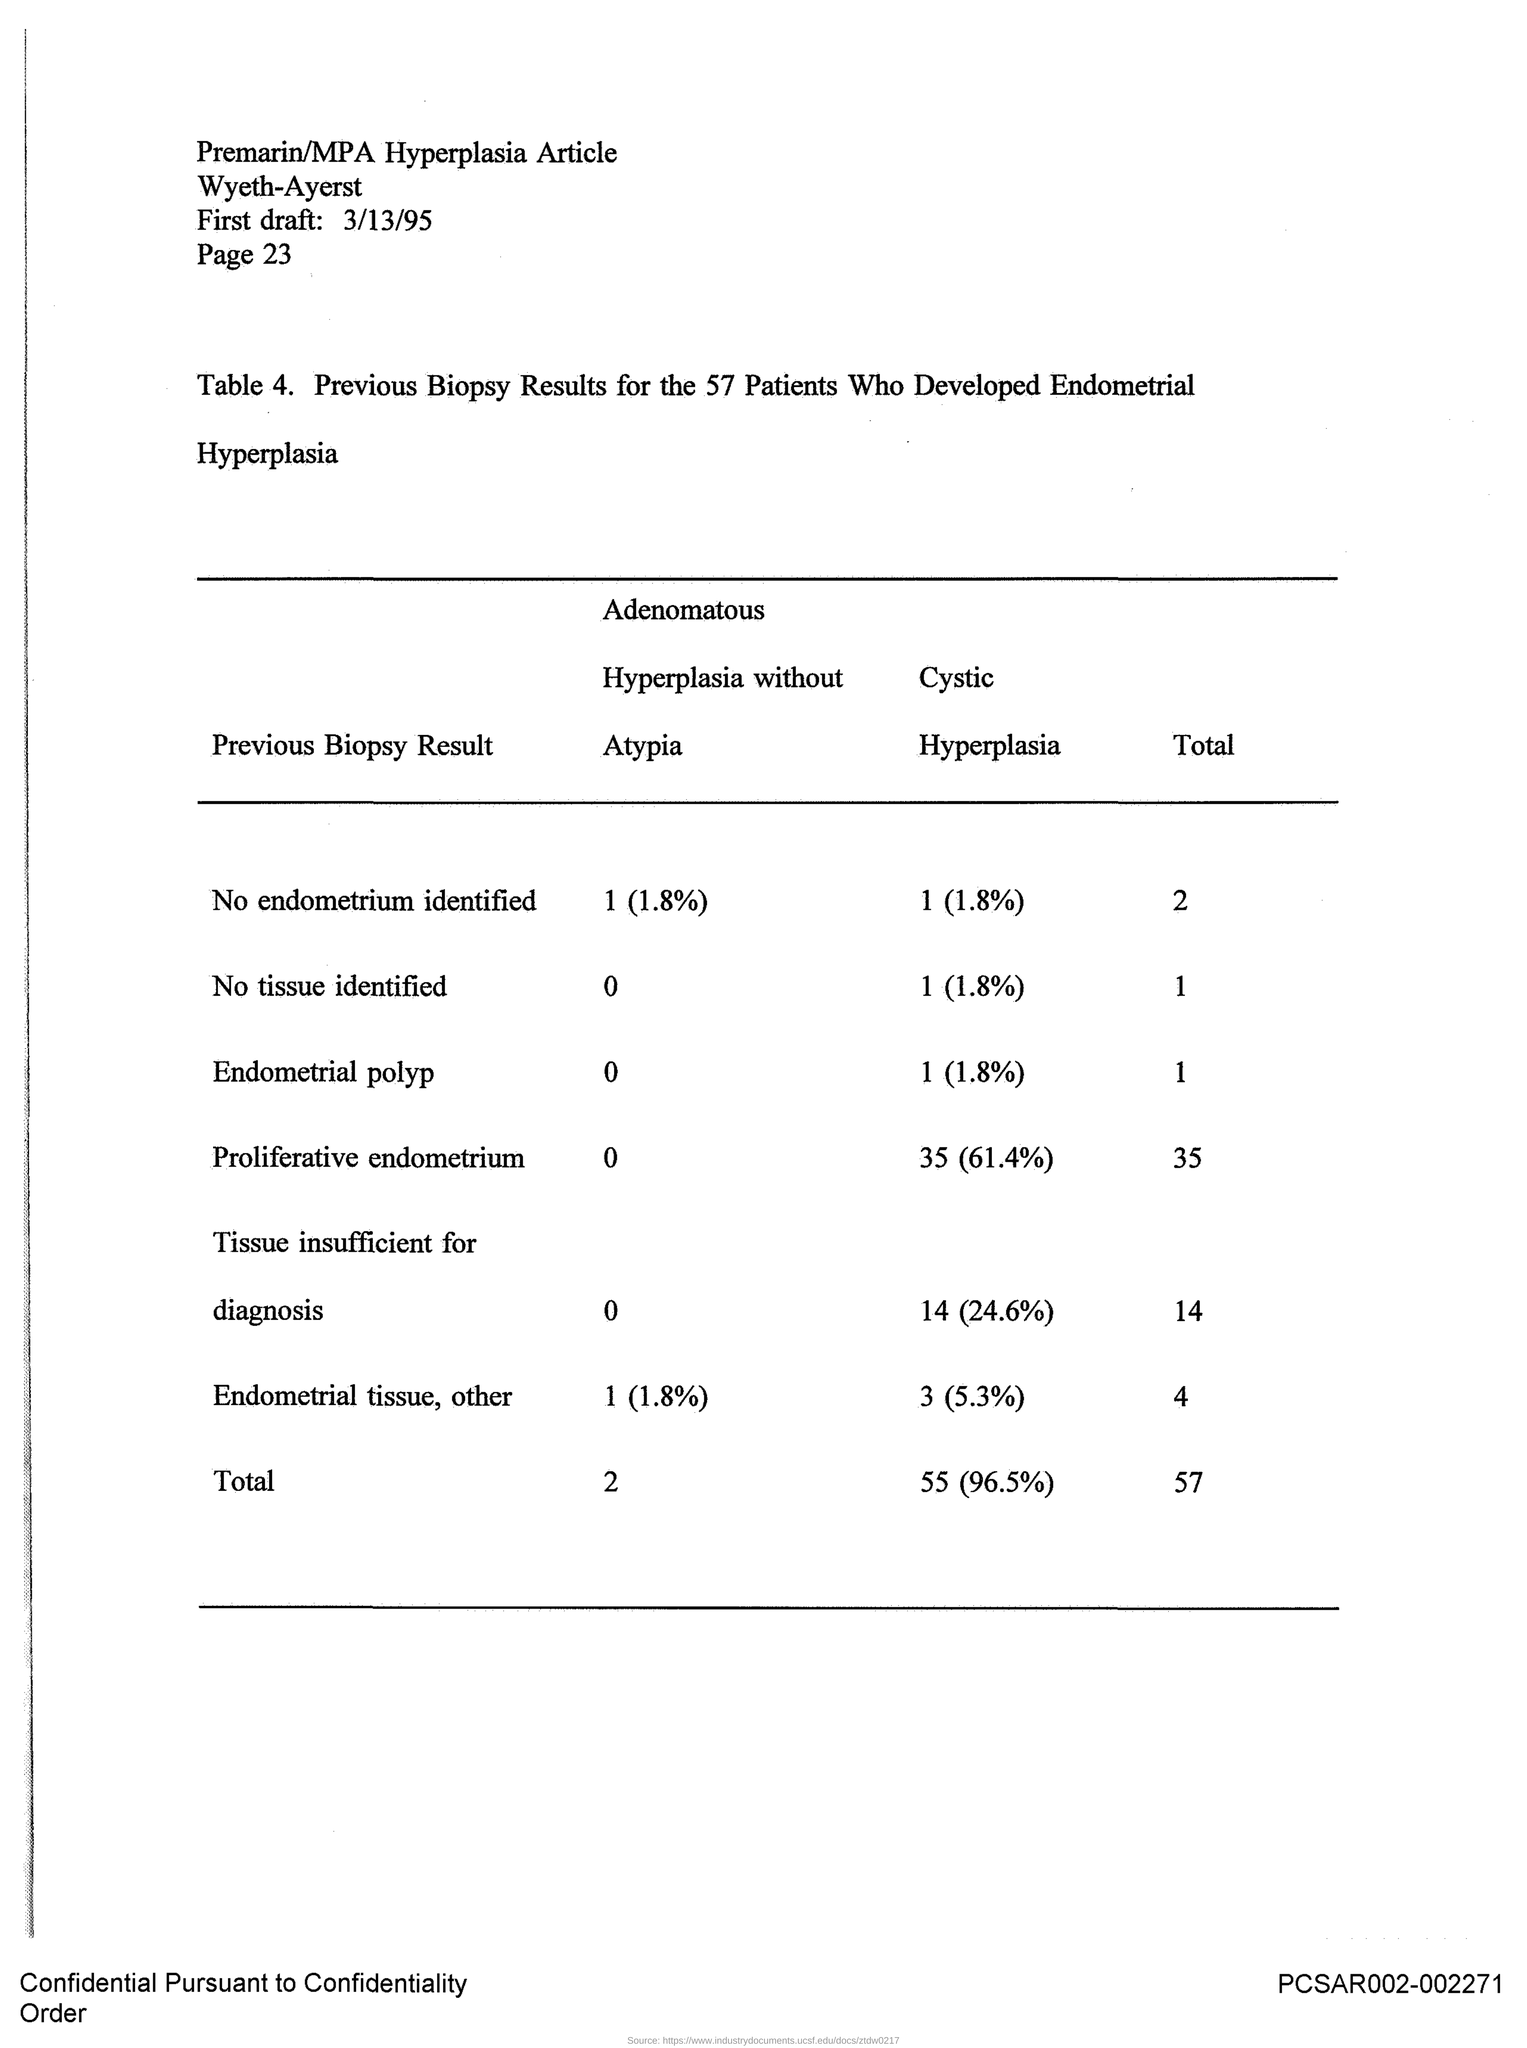Number of persons Biopsy results is shown in the document?
Your answer should be very brief. 57. 